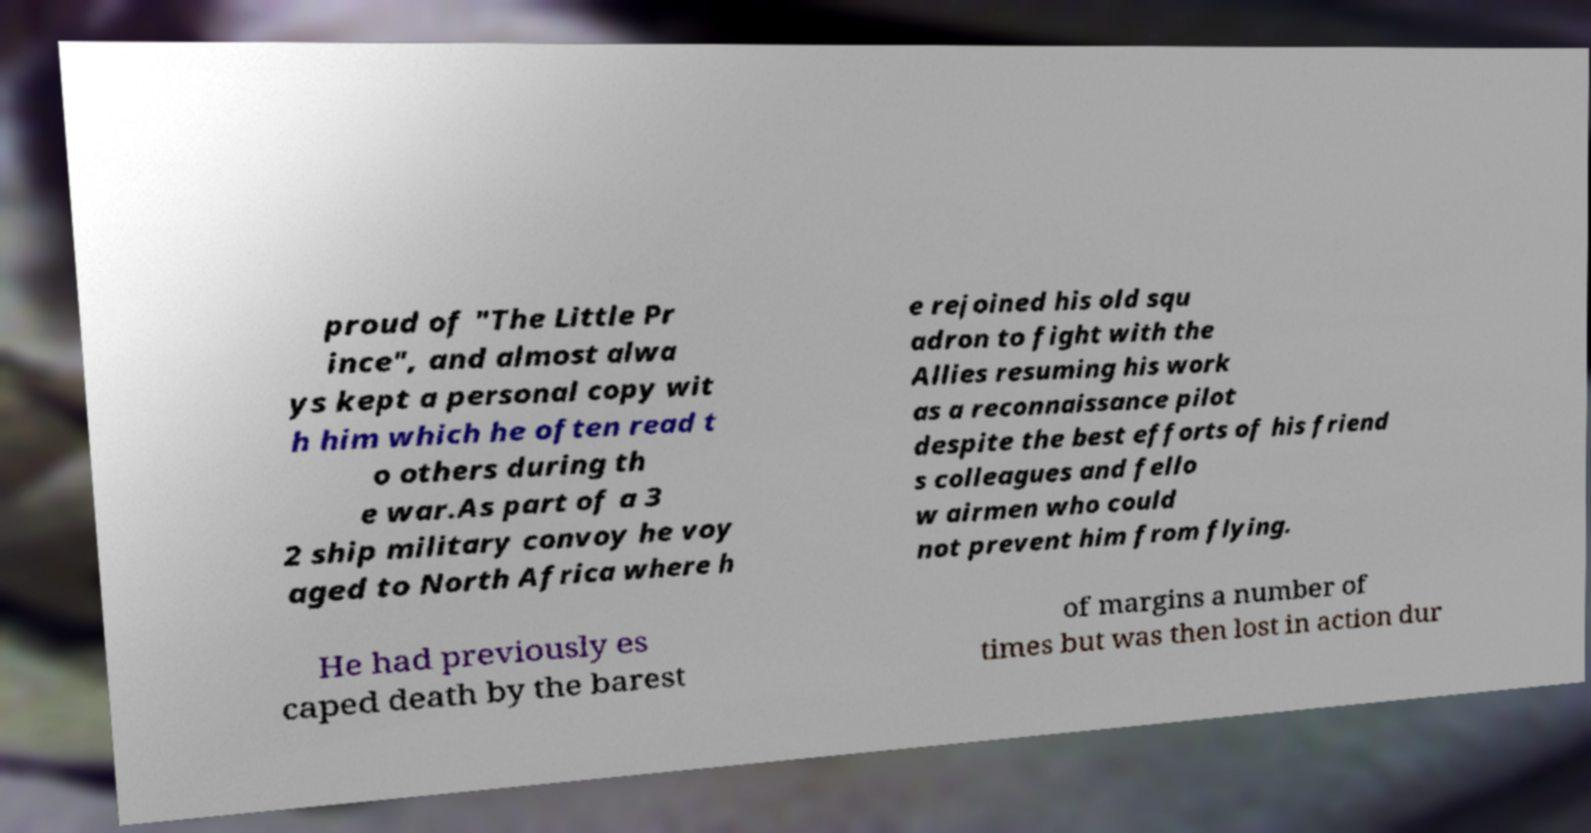Can you read and provide the text displayed in the image?This photo seems to have some interesting text. Can you extract and type it out for me? proud of "The Little Pr ince", and almost alwa ys kept a personal copy wit h him which he often read t o others during th e war.As part of a 3 2 ship military convoy he voy aged to North Africa where h e rejoined his old squ adron to fight with the Allies resuming his work as a reconnaissance pilot despite the best efforts of his friend s colleagues and fello w airmen who could not prevent him from flying. He had previously es caped death by the barest of margins a number of times but was then lost in action dur 